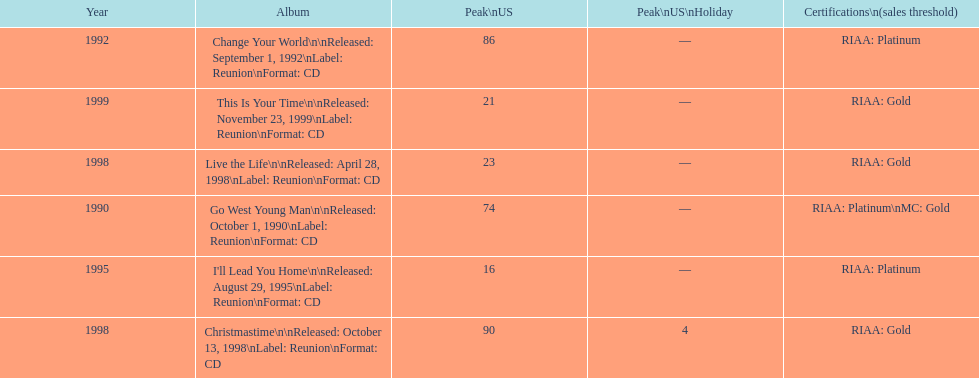How many album entries are there? 6. 